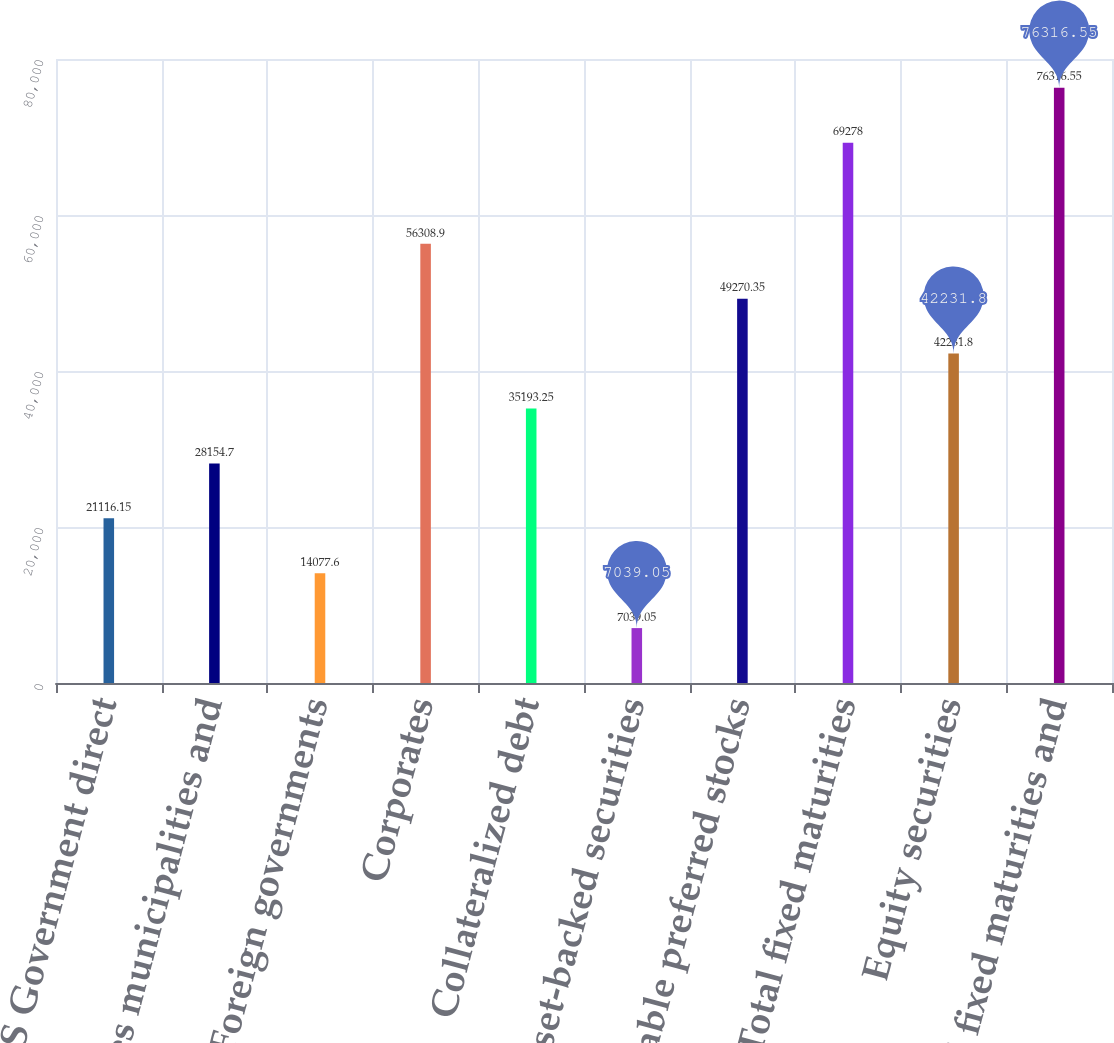Convert chart to OTSL. <chart><loc_0><loc_0><loc_500><loc_500><bar_chart><fcel>US Government direct<fcel>States municipalities and<fcel>Foreign governments<fcel>Corporates<fcel>Collateralized debt<fcel>Other asset-backed securities<fcel>Redeemable preferred stocks<fcel>Total fixed maturities<fcel>Equity securities<fcel>Total fixed maturities and<nl><fcel>21116.2<fcel>28154.7<fcel>14077.6<fcel>56308.9<fcel>35193.2<fcel>7039.05<fcel>49270.3<fcel>69278<fcel>42231.8<fcel>76316.6<nl></chart> 